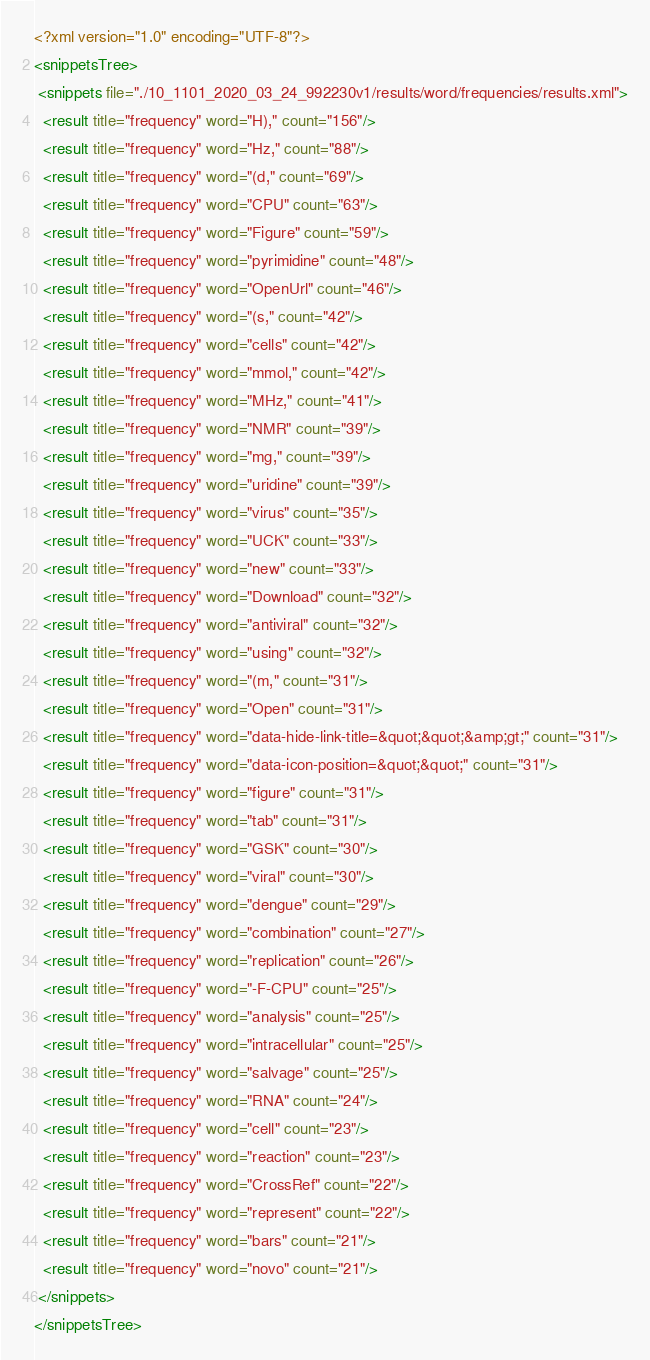Convert code to text. <code><loc_0><loc_0><loc_500><loc_500><_XML_><?xml version="1.0" encoding="UTF-8"?>
<snippetsTree>
 <snippets file="./10_1101_2020_03_24_992230v1/results/word/frequencies/results.xml">
  <result title="frequency" word="H)," count="156"/>
  <result title="frequency" word="Hz," count="88"/>
  <result title="frequency" word="(d," count="69"/>
  <result title="frequency" word="CPU" count="63"/>
  <result title="frequency" word="Figure" count="59"/>
  <result title="frequency" word="pyrimidine" count="48"/>
  <result title="frequency" word="OpenUrl" count="46"/>
  <result title="frequency" word="(s," count="42"/>
  <result title="frequency" word="cells" count="42"/>
  <result title="frequency" word="mmol," count="42"/>
  <result title="frequency" word="MHz," count="41"/>
  <result title="frequency" word="NMR" count="39"/>
  <result title="frequency" word="mg," count="39"/>
  <result title="frequency" word="uridine" count="39"/>
  <result title="frequency" word="virus" count="35"/>
  <result title="frequency" word="UCK" count="33"/>
  <result title="frequency" word="new" count="33"/>
  <result title="frequency" word="Download" count="32"/>
  <result title="frequency" word="antiviral" count="32"/>
  <result title="frequency" word="using" count="32"/>
  <result title="frequency" word="(m," count="31"/>
  <result title="frequency" word="Open" count="31"/>
  <result title="frequency" word="data-hide-link-title=&quot;&quot;&amp;gt;" count="31"/>
  <result title="frequency" word="data-icon-position=&quot;&quot;" count="31"/>
  <result title="frequency" word="figure" count="31"/>
  <result title="frequency" word="tab" count="31"/>
  <result title="frequency" word="GSK" count="30"/>
  <result title="frequency" word="viral" count="30"/>
  <result title="frequency" word="dengue" count="29"/>
  <result title="frequency" word="combination" count="27"/>
  <result title="frequency" word="replication" count="26"/>
  <result title="frequency" word="-F-CPU" count="25"/>
  <result title="frequency" word="analysis" count="25"/>
  <result title="frequency" word="intracellular" count="25"/>
  <result title="frequency" word="salvage" count="25"/>
  <result title="frequency" word="RNA" count="24"/>
  <result title="frequency" word="cell" count="23"/>
  <result title="frequency" word="reaction" count="23"/>
  <result title="frequency" word="CrossRef" count="22"/>
  <result title="frequency" word="represent" count="22"/>
  <result title="frequency" word="bars" count="21"/>
  <result title="frequency" word="novo" count="21"/>
 </snippets>
</snippetsTree>
</code> 